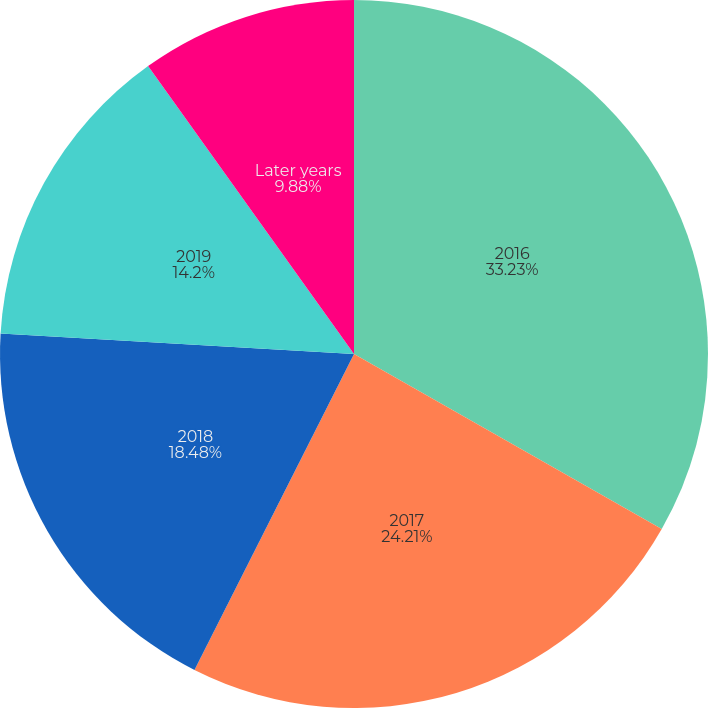Convert chart to OTSL. <chart><loc_0><loc_0><loc_500><loc_500><pie_chart><fcel>2016<fcel>2017<fcel>2018<fcel>2019<fcel>Later years<nl><fcel>33.23%<fcel>24.21%<fcel>18.48%<fcel>14.2%<fcel>9.88%<nl></chart> 